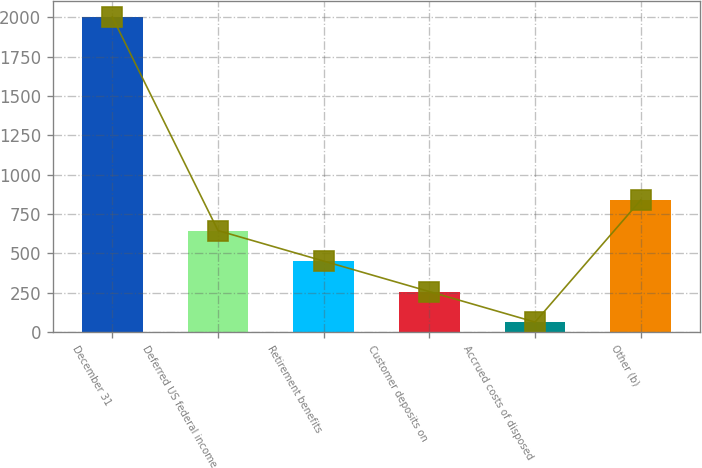Convert chart to OTSL. <chart><loc_0><loc_0><loc_500><loc_500><bar_chart><fcel>December 31<fcel>Deferred US federal income<fcel>Retirement benefits<fcel>Customer deposits on<fcel>Accrued costs of disposed<fcel>Other (b)<nl><fcel>2003<fcel>645<fcel>451<fcel>257<fcel>63<fcel>839<nl></chart> 